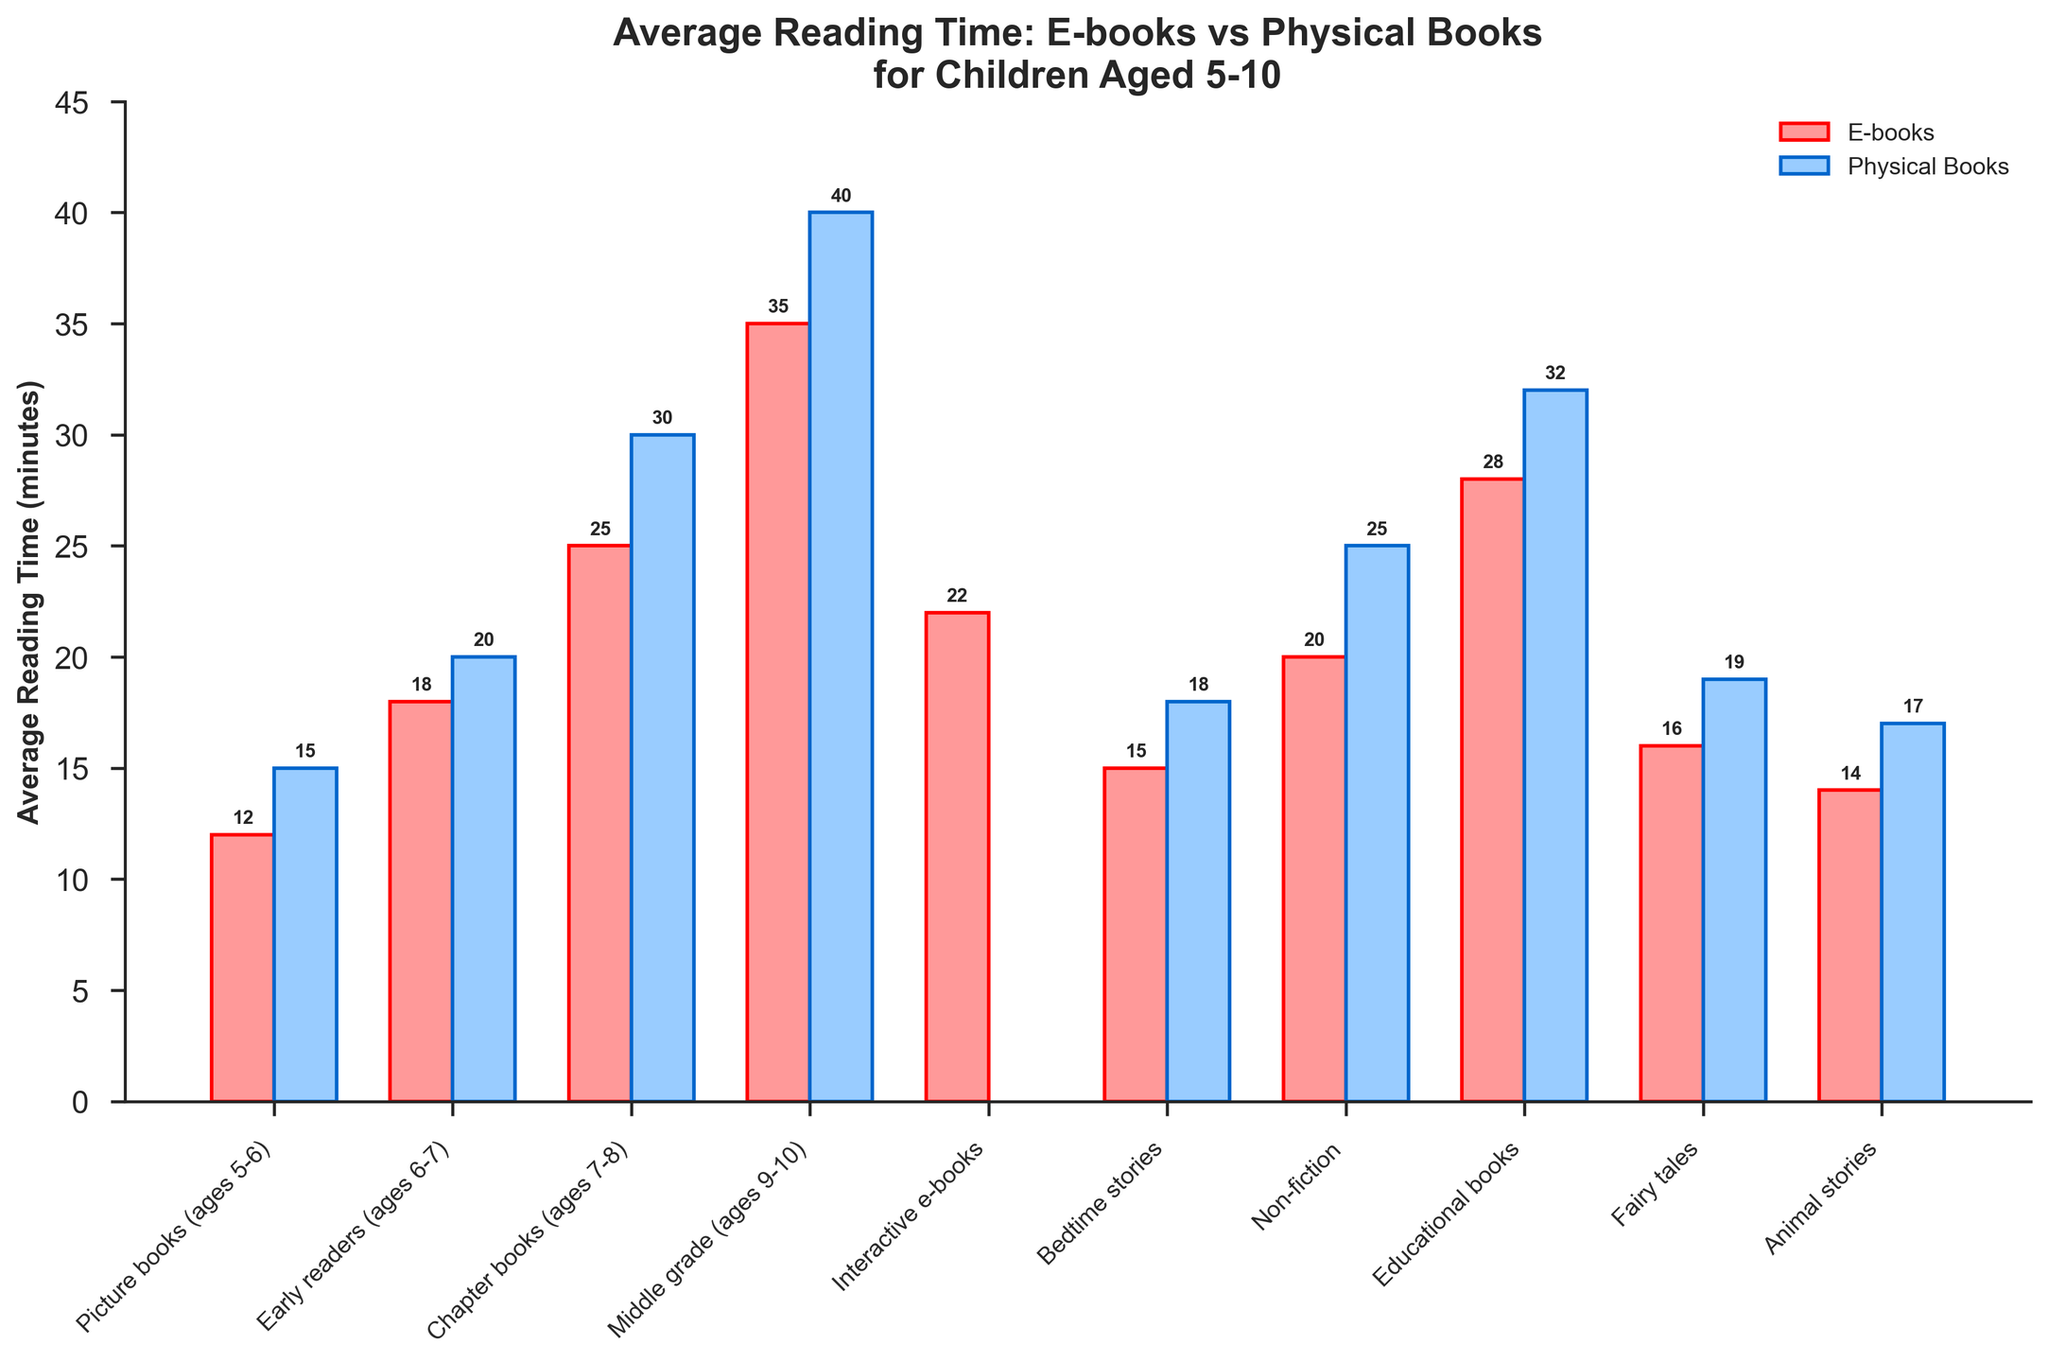Which category has the highest average reading time for physical books? The highest bar among physical books represents the highest reading time. By comparing the heights, we see that "Middle grade (ages 9-10)" has the tallest bar for physical books with 40 minutes.
Answer: Middle grade (ages 9-10) In which category do children spend more time reading e-books compared to physical books? Check each category to see if the bar for e-books is taller than the bar for physical books:
All categories except "Interactive e-books", which doesn't have a value for physical books, have physical books with a higher reading time. 
So, e-books do not surpass physical books in any category except the one with no physical book data.
Answer: Interactive e-books What is the total average reading time for all e-books categories combined? Add the average reading times for all e-books categories:
12 (Picture books) + 18 (Early readers) + 25 (Chapter books) + 35 (Middle grade) + 22 (Interactive e-books) + 15 (Bedtime stories) + 20 (Non-fiction) + 28 (Educational books) + 16 (Fairy tales) + 14 (Animal stories) = 205 minutes.
Answer: 205 What is the average difference in reading time between e-books and physical books for categories that have both? First, calculate the difference for each applicable category and then find the average:
(Picture books: 3, Early readers: 2, Chapter books: 5, Middle grade: 5, Bedtime stories: 3, Non-fiction: 5, Educational books: 4, Fairy tales: 3, Animal stories: 3)
Total differences: 3 + 2 + 5 + 5 + 3 + 5 + 4 + 3 + 3 = 33
Average difference = 33 / 9 = 3.67 minutes.
Answer: 3.67 How much more time do children spend on average reading physical books than e-books for Middle-grade (ages 9-10)? The physical book reading time for Middle-grade (ages 9-10) is 40 minutes and the e-book reading time is 35 minutes. The difference is 40 - 35 = 5 minutes.
Answer: 5 What is the average reading time for e-books in the categories useful for children aged 5-6? Two relevant categories are Picture books (12 minutes) and Bedtime stories (15 minutes). The average is (12 + 15) / 2 = 13.5 minutes.
Answer: 13.5 